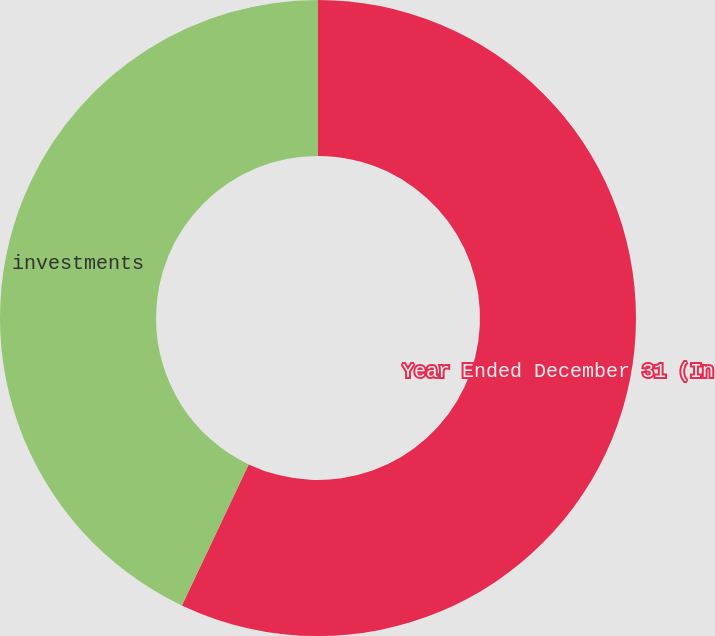Convert chart to OTSL. <chart><loc_0><loc_0><loc_500><loc_500><pie_chart><fcel>Year Ended December 31 (In<fcel>investments<nl><fcel>57.04%<fcel>42.96%<nl></chart> 